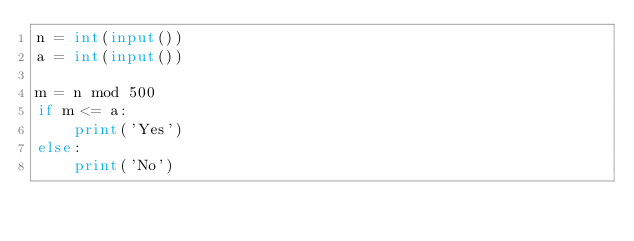Convert code to text. <code><loc_0><loc_0><loc_500><loc_500><_Python_>n = int(input())
a = int(input())

m = n mod 500
if m <= a:
    print('Yes')
else:
    print('No')

</code> 